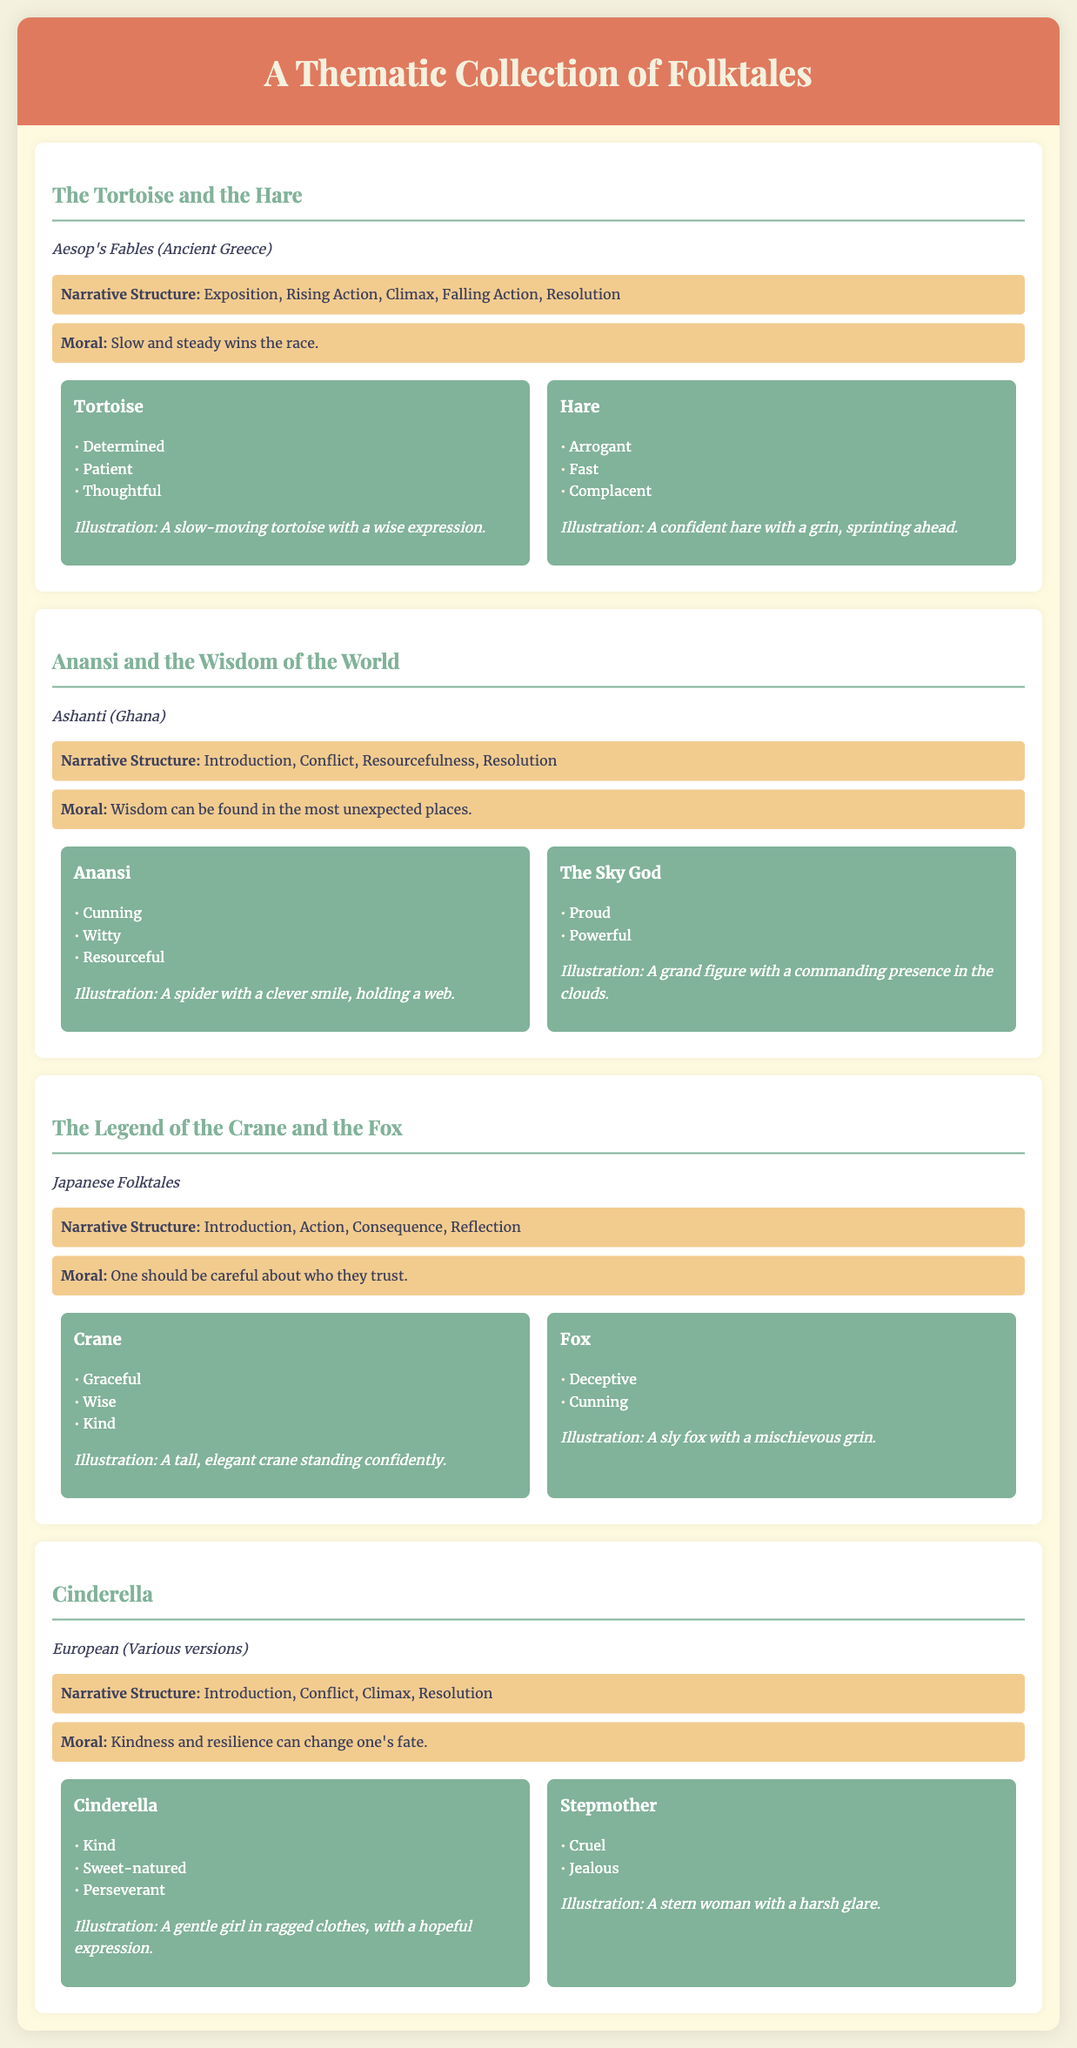What is the title of the first folktale? The title of the first folktale is included in the section labeled with the name of the tale.
Answer: The Tortoise and the Hare What culture is associated with "Anansi and the Wisdom of the World"? Each folktale includes a line specifying its cultural origin, which identifies where the tale comes from.
Answer: Ashanti (Ghana) What is the moral of "Cinderella"? Each folktale specifies a moral that is summarized in a line labeled "Moral," indicating the lesson to be learned.
Answer: Kindness and resilience can change one's fate Which character is described as "Cunning" in "Anansi and the Wisdom of the World"? The traits of each character are listed under their corresponding section, revealing their characteristics directly.
Answer: Anansi What narrative structure is found in "The Legend of the Crane and the Fox"? Each folktale has a narrative structure outlined, indicating the progression of the story.
Answer: Introduction, Action, Consequence, Reflection Which character from "The Tortoise and the Hare" is described as "Complacent"? The traits of characters in each folktale are detailed, allowing identification of specific characteristics associated with them.
Answer: Hare What is the illustration description for the Crane? Each character includes a brief description of their illustration, providing visual cues associated with them.
Answer: A tall, elegant crane standing confidently How many characters are identified in "Cinderella"? The number of characters can be determined by counting the sections that describe each character within the folktale.
Answer: 2 